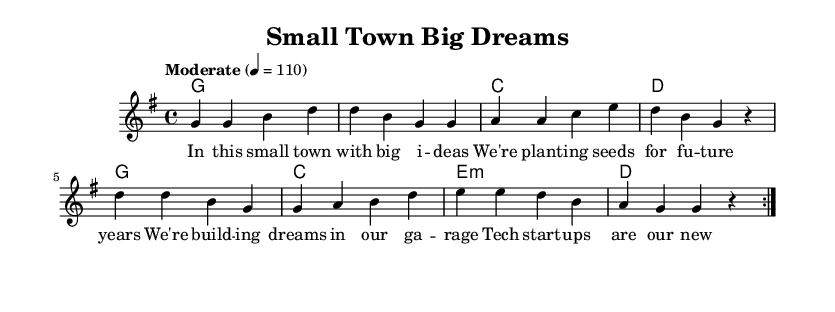What is the key signature of this music? The key signature is G major, which has one sharp (F#).
Answer: G major What is the time signature? The time signature is 4/4, indicating four beats per measure.
Answer: 4/4 What is the tempo marking for this piece? The tempo marking is "Moderate" with a speed of 110 beats per minute.
Answer: Moderate 110 What type of chords are used in the chorus section? The chorus section contains a combination of major and minor chords, specifically C major, E minor, and G major.
Answer: Major and minor How many times is the verse repeated? The verse is repeated twice as indicated by the repeat volta marking at the beginning of the section.
Answer: Twice What is a recurring theme in the lyrics? A recurring theme is innovation and entrepreneurship in a small town setting. This can be inferred from the phrases mentioning "big ideas" and "tech start-ups."
Answer: Innovation and entrepreneurship 